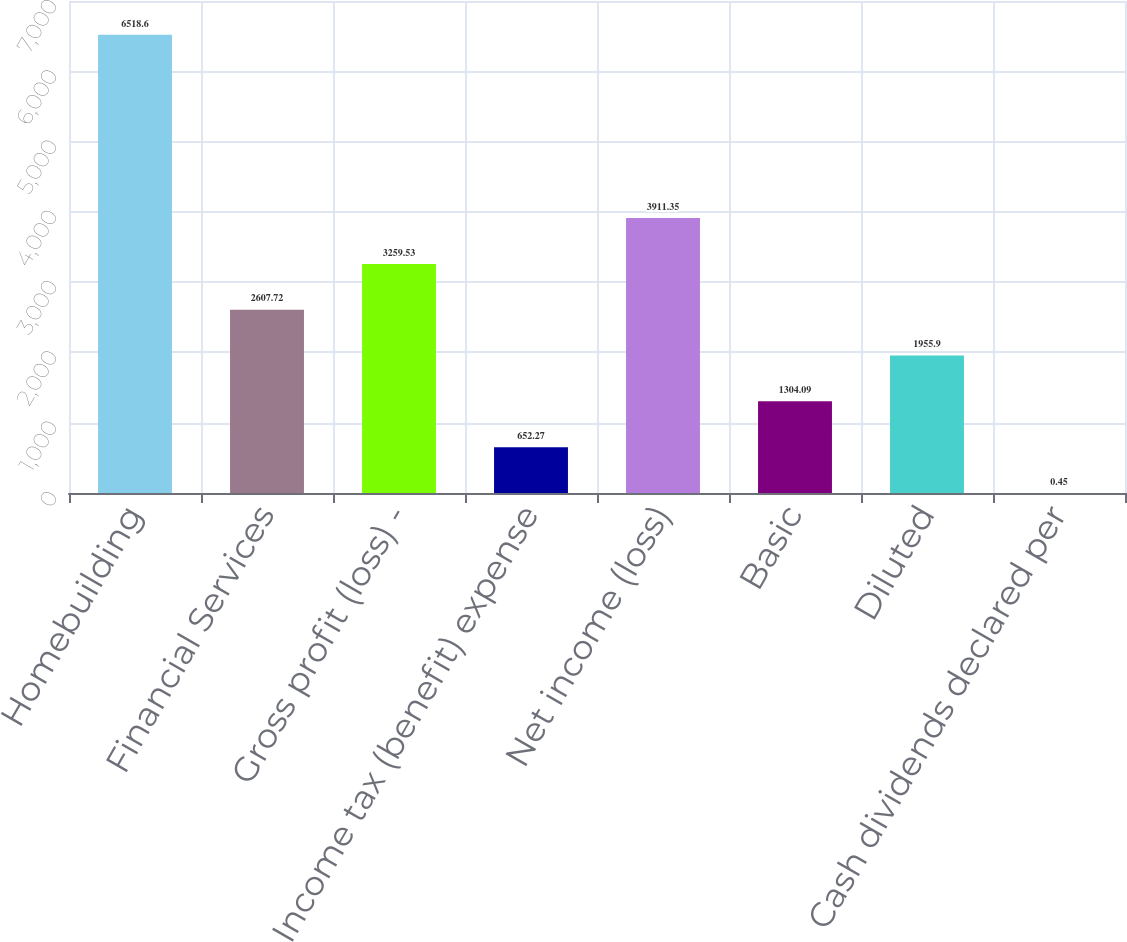Convert chart to OTSL. <chart><loc_0><loc_0><loc_500><loc_500><bar_chart><fcel>Homebuilding<fcel>Financial Services<fcel>Gross profit (loss) -<fcel>Income tax (benefit) expense<fcel>Net income (loss)<fcel>Basic<fcel>Diluted<fcel>Cash dividends declared per<nl><fcel>6518.6<fcel>2607.72<fcel>3259.53<fcel>652.27<fcel>3911.35<fcel>1304.09<fcel>1955.9<fcel>0.45<nl></chart> 